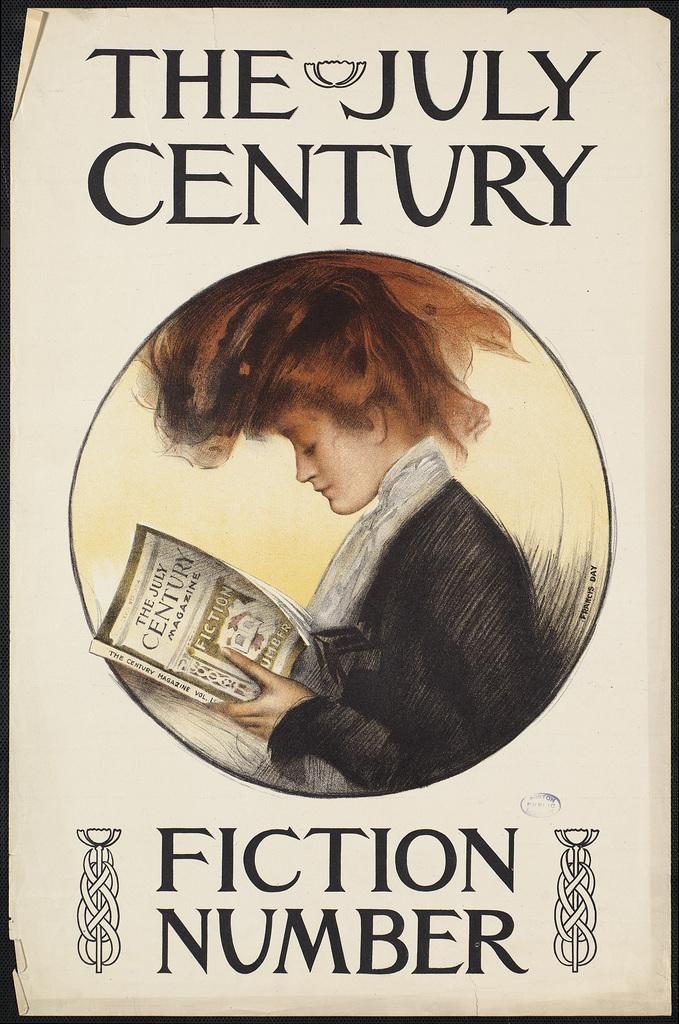<image>
Render a clear and concise summary of the photo. a book that says 'the july century fiction number' on it 